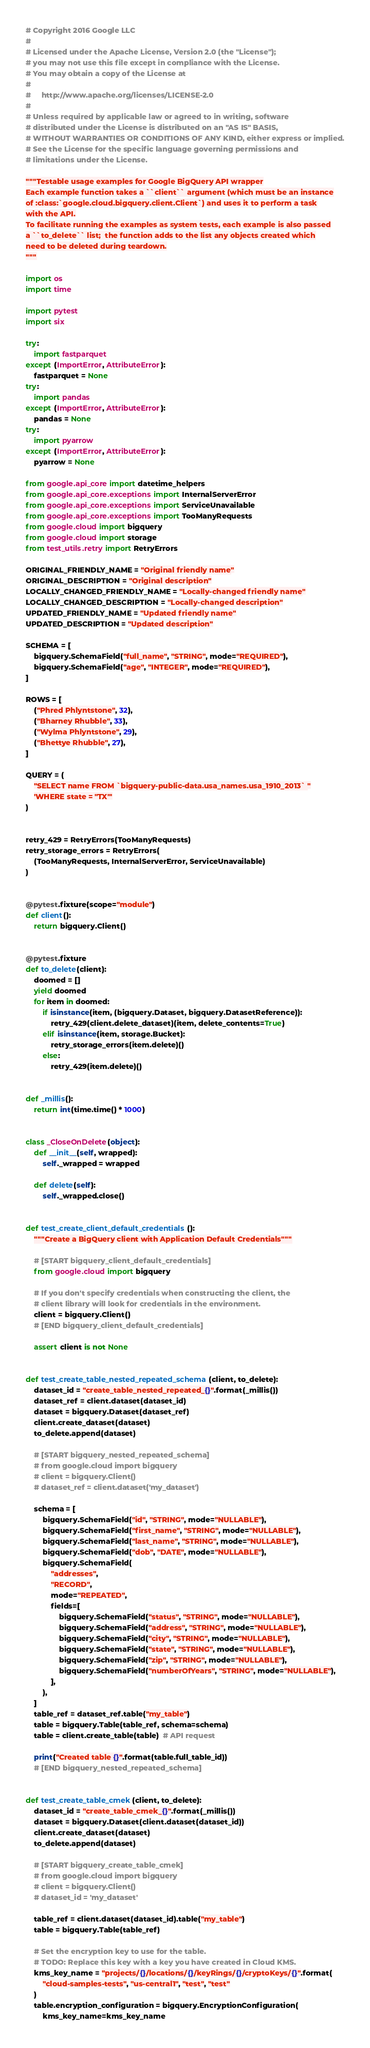Convert code to text. <code><loc_0><loc_0><loc_500><loc_500><_Python_># Copyright 2016 Google LLC
#
# Licensed under the Apache License, Version 2.0 (the "License");
# you may not use this file except in compliance with the License.
# You may obtain a copy of the License at
#
#     http://www.apache.org/licenses/LICENSE-2.0
#
# Unless required by applicable law or agreed to in writing, software
# distributed under the License is distributed on an "AS IS" BASIS,
# WITHOUT WARRANTIES OR CONDITIONS OF ANY KIND, either express or implied.
# See the License for the specific language governing permissions and
# limitations under the License.

"""Testable usage examples for Google BigQuery API wrapper
Each example function takes a ``client`` argument (which must be an instance
of :class:`google.cloud.bigquery.client.Client`) and uses it to perform a task
with the API.
To facilitate running the examples as system tests, each example is also passed
a ``to_delete`` list;  the function adds to the list any objects created which
need to be deleted during teardown.
"""

import os
import time

import pytest
import six

try:
    import fastparquet
except (ImportError, AttributeError):
    fastparquet = None
try:
    import pandas
except (ImportError, AttributeError):
    pandas = None
try:
    import pyarrow
except (ImportError, AttributeError):
    pyarrow = None

from google.api_core import datetime_helpers
from google.api_core.exceptions import InternalServerError
from google.api_core.exceptions import ServiceUnavailable
from google.api_core.exceptions import TooManyRequests
from google.cloud import bigquery
from google.cloud import storage
from test_utils.retry import RetryErrors

ORIGINAL_FRIENDLY_NAME = "Original friendly name"
ORIGINAL_DESCRIPTION = "Original description"
LOCALLY_CHANGED_FRIENDLY_NAME = "Locally-changed friendly name"
LOCALLY_CHANGED_DESCRIPTION = "Locally-changed description"
UPDATED_FRIENDLY_NAME = "Updated friendly name"
UPDATED_DESCRIPTION = "Updated description"

SCHEMA = [
    bigquery.SchemaField("full_name", "STRING", mode="REQUIRED"),
    bigquery.SchemaField("age", "INTEGER", mode="REQUIRED"),
]

ROWS = [
    ("Phred Phlyntstone", 32),
    ("Bharney Rhubble", 33),
    ("Wylma Phlyntstone", 29),
    ("Bhettye Rhubble", 27),
]

QUERY = (
    "SELECT name FROM `bigquery-public-data.usa_names.usa_1910_2013` "
    'WHERE state = "TX"'
)


retry_429 = RetryErrors(TooManyRequests)
retry_storage_errors = RetryErrors(
    (TooManyRequests, InternalServerError, ServiceUnavailable)
)


@pytest.fixture(scope="module")
def client():
    return bigquery.Client()


@pytest.fixture
def to_delete(client):
    doomed = []
    yield doomed
    for item in doomed:
        if isinstance(item, (bigquery.Dataset, bigquery.DatasetReference)):
            retry_429(client.delete_dataset)(item, delete_contents=True)
        elif isinstance(item, storage.Bucket):
            retry_storage_errors(item.delete)()
        else:
            retry_429(item.delete)()


def _millis():
    return int(time.time() * 1000)


class _CloseOnDelete(object):
    def __init__(self, wrapped):
        self._wrapped = wrapped

    def delete(self):
        self._wrapped.close()


def test_create_client_default_credentials():
    """Create a BigQuery client with Application Default Credentials"""

    # [START bigquery_client_default_credentials]
    from google.cloud import bigquery

    # If you don't specify credentials when constructing the client, the
    # client library will look for credentials in the environment.
    client = bigquery.Client()
    # [END bigquery_client_default_credentials]

    assert client is not None


def test_create_table_nested_repeated_schema(client, to_delete):
    dataset_id = "create_table_nested_repeated_{}".format(_millis())
    dataset_ref = client.dataset(dataset_id)
    dataset = bigquery.Dataset(dataset_ref)
    client.create_dataset(dataset)
    to_delete.append(dataset)

    # [START bigquery_nested_repeated_schema]
    # from google.cloud import bigquery
    # client = bigquery.Client()
    # dataset_ref = client.dataset('my_dataset')

    schema = [
        bigquery.SchemaField("id", "STRING", mode="NULLABLE"),
        bigquery.SchemaField("first_name", "STRING", mode="NULLABLE"),
        bigquery.SchemaField("last_name", "STRING", mode="NULLABLE"),
        bigquery.SchemaField("dob", "DATE", mode="NULLABLE"),
        bigquery.SchemaField(
            "addresses",
            "RECORD",
            mode="REPEATED",
            fields=[
                bigquery.SchemaField("status", "STRING", mode="NULLABLE"),
                bigquery.SchemaField("address", "STRING", mode="NULLABLE"),
                bigquery.SchemaField("city", "STRING", mode="NULLABLE"),
                bigquery.SchemaField("state", "STRING", mode="NULLABLE"),
                bigquery.SchemaField("zip", "STRING", mode="NULLABLE"),
                bigquery.SchemaField("numberOfYears", "STRING", mode="NULLABLE"),
            ],
        ),
    ]
    table_ref = dataset_ref.table("my_table")
    table = bigquery.Table(table_ref, schema=schema)
    table = client.create_table(table)  # API request

    print("Created table {}".format(table.full_table_id))
    # [END bigquery_nested_repeated_schema]


def test_create_table_cmek(client, to_delete):
    dataset_id = "create_table_cmek_{}".format(_millis())
    dataset = bigquery.Dataset(client.dataset(dataset_id))
    client.create_dataset(dataset)
    to_delete.append(dataset)

    # [START bigquery_create_table_cmek]
    # from google.cloud import bigquery
    # client = bigquery.Client()
    # dataset_id = 'my_dataset'

    table_ref = client.dataset(dataset_id).table("my_table")
    table = bigquery.Table(table_ref)

    # Set the encryption key to use for the table.
    # TODO: Replace this key with a key you have created in Cloud KMS.
    kms_key_name = "projects/{}/locations/{}/keyRings/{}/cryptoKeys/{}".format(
        "cloud-samples-tests", "us-central1", "test", "test"
    )
    table.encryption_configuration = bigquery.EncryptionConfiguration(
        kms_key_name=kms_key_name</code> 